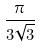Convert formula to latex. <formula><loc_0><loc_0><loc_500><loc_500>\frac { \pi } { 3 \sqrt { 3 } }</formula> 